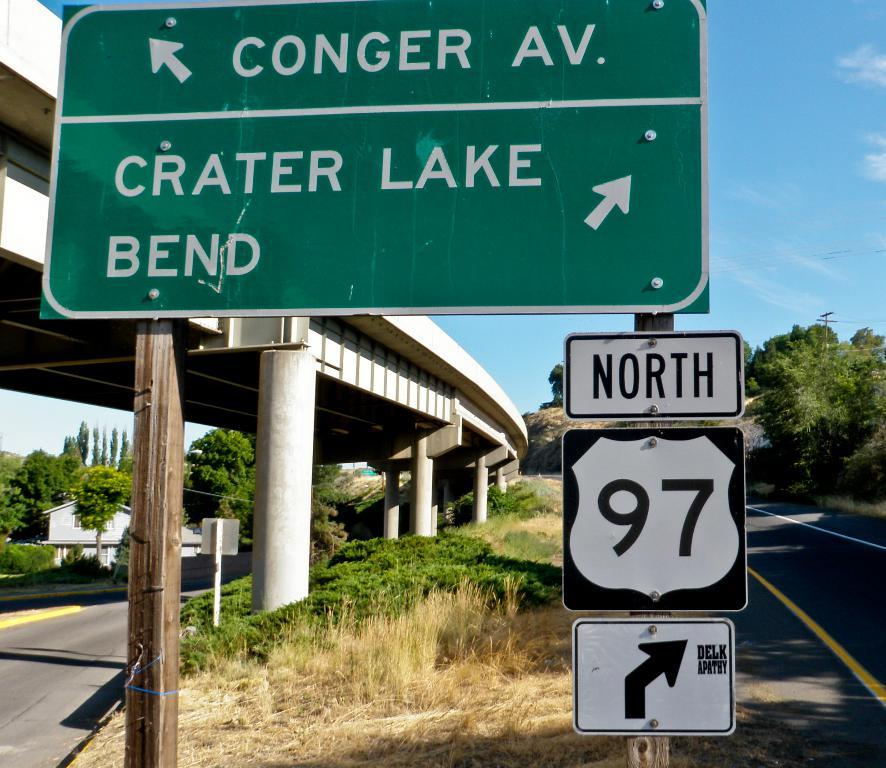<image>
Relay a brief, clear account of the picture shown. A green highway sign shows Crater Lake Bend to the right. 